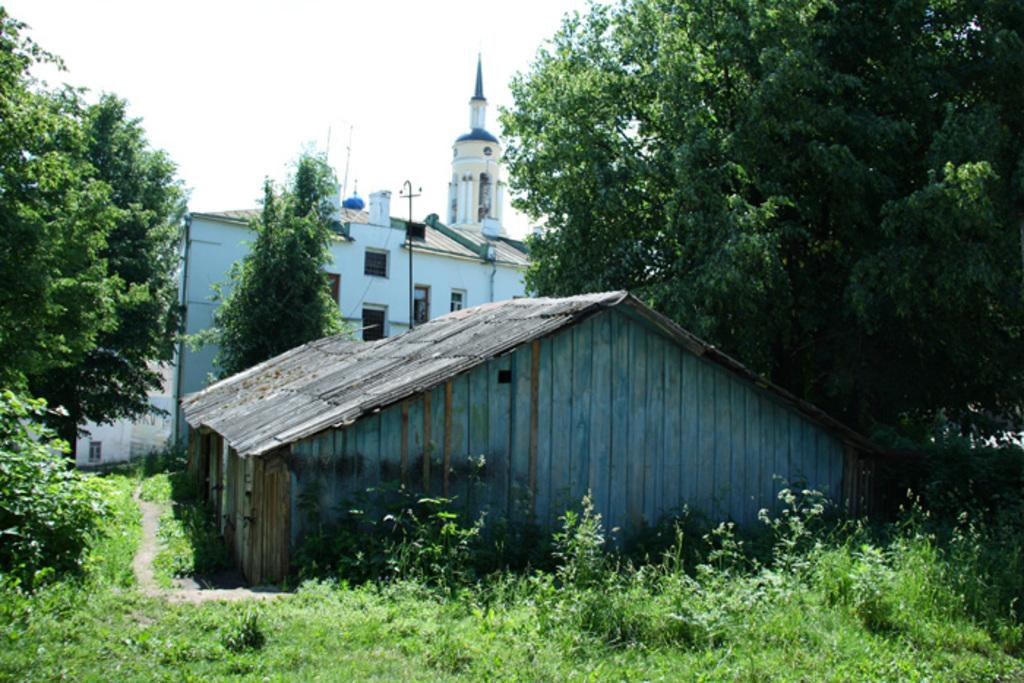What type of structure is visible in the image? There is a building and a house in the image. What is the ground made of in the image? Green grass is present at the bottom of the image. Where are the trees located in the image? There are trees on the left side and the right side of the image. What is visible at the top of the image? The sky is visible at the top of the image. What type of coat is the governor wearing in the image? There is no governor or coat present in the image. Is there a fire visible in the image? There is no fire present in the image. 